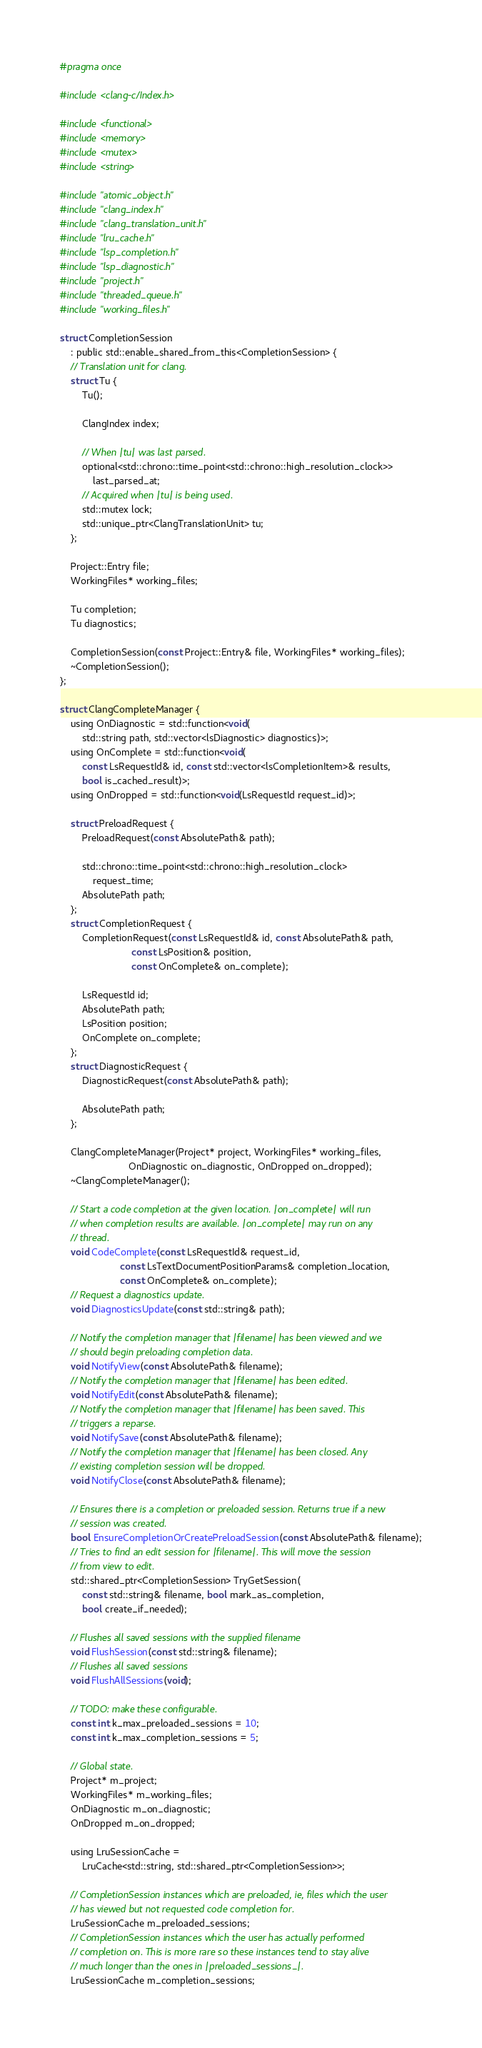Convert code to text. <code><loc_0><loc_0><loc_500><loc_500><_C_>#pragma once

#include <clang-c/Index.h>

#include <functional>
#include <memory>
#include <mutex>
#include <string>

#include "atomic_object.h"
#include "clang_index.h"
#include "clang_translation_unit.h"
#include "lru_cache.h"
#include "lsp_completion.h"
#include "lsp_diagnostic.h"
#include "project.h"
#include "threaded_queue.h"
#include "working_files.h"

struct CompletionSession
    : public std::enable_shared_from_this<CompletionSession> {
    // Translation unit for clang.
    struct Tu {
        Tu();

        ClangIndex index;

        // When |tu| was last parsed.
        optional<std::chrono::time_point<std::chrono::high_resolution_clock>>
            last_parsed_at;
        // Acquired when |tu| is being used.
        std::mutex lock;
        std::unique_ptr<ClangTranslationUnit> tu;
    };

    Project::Entry file;
    WorkingFiles* working_files;

    Tu completion;
    Tu diagnostics;

    CompletionSession(const Project::Entry& file, WorkingFiles* working_files);
    ~CompletionSession();
};

struct ClangCompleteManager {
    using OnDiagnostic = std::function<void(
        std::string path, std::vector<lsDiagnostic> diagnostics)>;
    using OnComplete = std::function<void(
        const LsRequestId& id, const std::vector<lsCompletionItem>& results,
        bool is_cached_result)>;
    using OnDropped = std::function<void(LsRequestId request_id)>;

    struct PreloadRequest {
        PreloadRequest(const AbsolutePath& path);

        std::chrono::time_point<std::chrono::high_resolution_clock>
            request_time;
        AbsolutePath path;
    };
    struct CompletionRequest {
        CompletionRequest(const LsRequestId& id, const AbsolutePath& path,
                          const LsPosition& position,
                          const OnComplete& on_complete);

        LsRequestId id;
        AbsolutePath path;
        LsPosition position;
        OnComplete on_complete;
    };
    struct DiagnosticRequest {
        DiagnosticRequest(const AbsolutePath& path);

        AbsolutePath path;
    };

    ClangCompleteManager(Project* project, WorkingFiles* working_files,
                         OnDiagnostic on_diagnostic, OnDropped on_dropped);
    ~ClangCompleteManager();

    // Start a code completion at the given location. |on_complete| will run
    // when completion results are available. |on_complete| may run on any
    // thread.
    void CodeComplete(const LsRequestId& request_id,
                      const LsTextDocumentPositionParams& completion_location,
                      const OnComplete& on_complete);
    // Request a diagnostics update.
    void DiagnosticsUpdate(const std::string& path);

    // Notify the completion manager that |filename| has been viewed and we
    // should begin preloading completion data.
    void NotifyView(const AbsolutePath& filename);
    // Notify the completion manager that |filename| has been edited.
    void NotifyEdit(const AbsolutePath& filename);
    // Notify the completion manager that |filename| has been saved. This
    // triggers a reparse.
    void NotifySave(const AbsolutePath& filename);
    // Notify the completion manager that |filename| has been closed. Any
    // existing completion session will be dropped.
    void NotifyClose(const AbsolutePath& filename);

    // Ensures there is a completion or preloaded session. Returns true if a new
    // session was created.
    bool EnsureCompletionOrCreatePreloadSession(const AbsolutePath& filename);
    // Tries to find an edit session for |filename|. This will move the session
    // from view to edit.
    std::shared_ptr<CompletionSession> TryGetSession(
        const std::string& filename, bool mark_as_completion,
        bool create_if_needed);

    // Flushes all saved sessions with the supplied filename
    void FlushSession(const std::string& filename);
    // Flushes all saved sessions
    void FlushAllSessions(void);

    // TODO: make these configurable.
    const int k_max_preloaded_sessions = 10;
    const int k_max_completion_sessions = 5;

    // Global state.
    Project* m_project;
    WorkingFiles* m_working_files;
    OnDiagnostic m_on_diagnostic;
    OnDropped m_on_dropped;

    using LruSessionCache =
        LruCache<std::string, std::shared_ptr<CompletionSession>>;

    // CompletionSession instances which are preloaded, ie, files which the user
    // has viewed but not requested code completion for.
    LruSessionCache m_preloaded_sessions;
    // CompletionSession instances which the user has actually performed
    // completion on. This is more rare so these instances tend to stay alive
    // much longer than the ones in |preloaded_sessions_|.
    LruSessionCache m_completion_sessions;</code> 